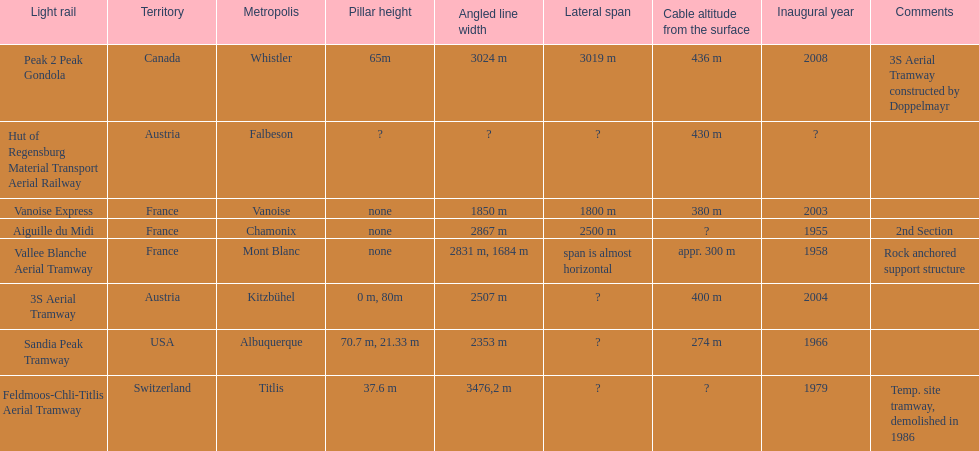Can you parse all the data within this table? {'header': ['Light rail', 'Territory', 'Metropolis', 'Pillar height', 'Angled line width', 'Lateral span', 'Cable altitude from the surface', 'Inaugural year', 'Comments'], 'rows': [['Peak 2 Peak Gondola', 'Canada', 'Whistler', '65m', '3024 m', '3019 m', '436 m', '2008', '3S Aerial Tramway constructed by Doppelmayr'], ['Hut of Regensburg Material Transport Aerial Railway', 'Austria', 'Falbeson', '?', '?', '?', '430 m', '?', ''], ['Vanoise Express', 'France', 'Vanoise', 'none', '1850 m', '1800 m', '380 m', '2003', ''], ['Aiguille du Midi', 'France', 'Chamonix', 'none', '2867 m', '2500 m', '?', '1955', '2nd Section'], ['Vallee Blanche Aerial Tramway', 'France', 'Mont Blanc', 'none', '2831 m, 1684 m', 'span is almost horizontal', 'appr. 300 m', '1958', 'Rock anchored support structure'], ['3S Aerial Tramway', 'Austria', 'Kitzbühel', '0 m, 80m', '2507 m', '?', '400 m', '2004', ''], ['Sandia Peak Tramway', 'USA', 'Albuquerque', '70.7 m, 21.33 m', '2353 m', '?', '274 m', '1966', ''], ['Feldmoos-Chli-Titlis Aerial Tramway', 'Switzerland', 'Titlis', '37.6 m', '3476,2 m', '?', '?', '1979', 'Temp. site tramway, demolished in 1986']]} At least how many aerial tramways were inaugurated after 1970? 4. 